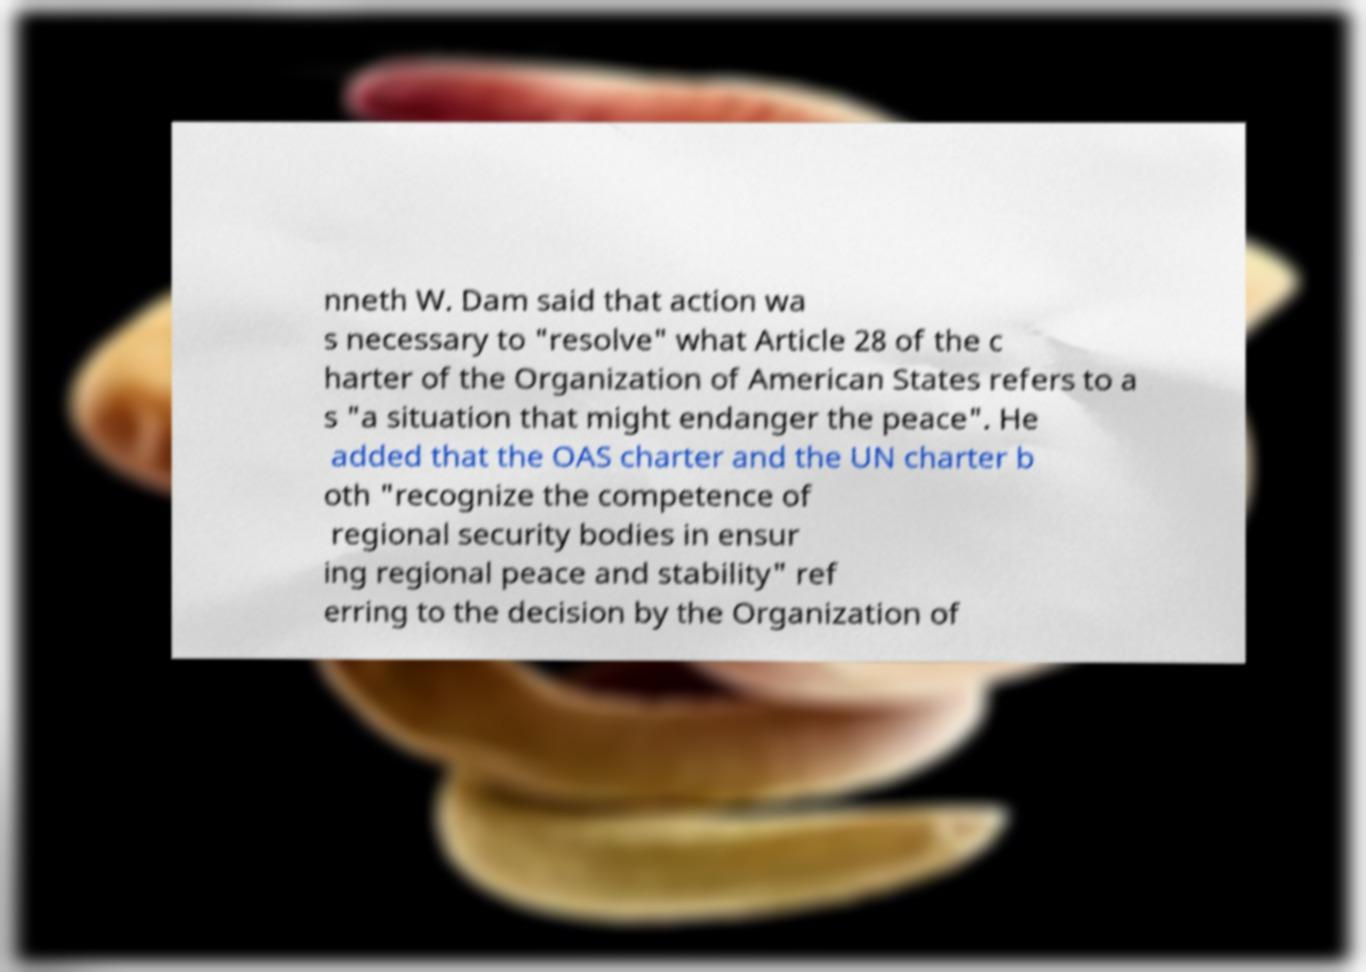For documentation purposes, I need the text within this image transcribed. Could you provide that? nneth W. Dam said that action wa s necessary to "resolve" what Article 28 of the c harter of the Organization of American States refers to a s "a situation that might endanger the peace". He added that the OAS charter and the UN charter b oth "recognize the competence of regional security bodies in ensur ing regional peace and stability" ref erring to the decision by the Organization of 